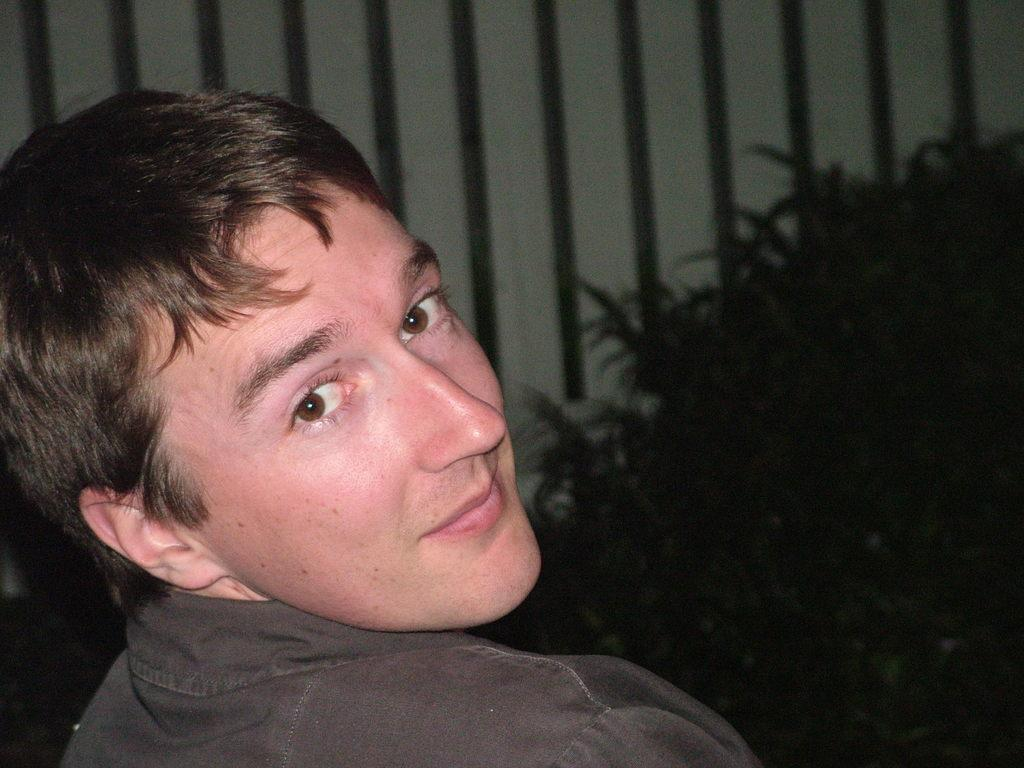Who is present in the image? There is a man in the image. What is the man doing in the image? The man is smiling in the image. What else can be seen in the image besides the man? There is a plant in the image. Can you tell me how many lakes are visible in the image? There are no lakes present in the image. What type of lumber is being used to construct the plant in the image? There is no lumber present in the image, as it features a man smiling and a plant, but no construction or lumber. 